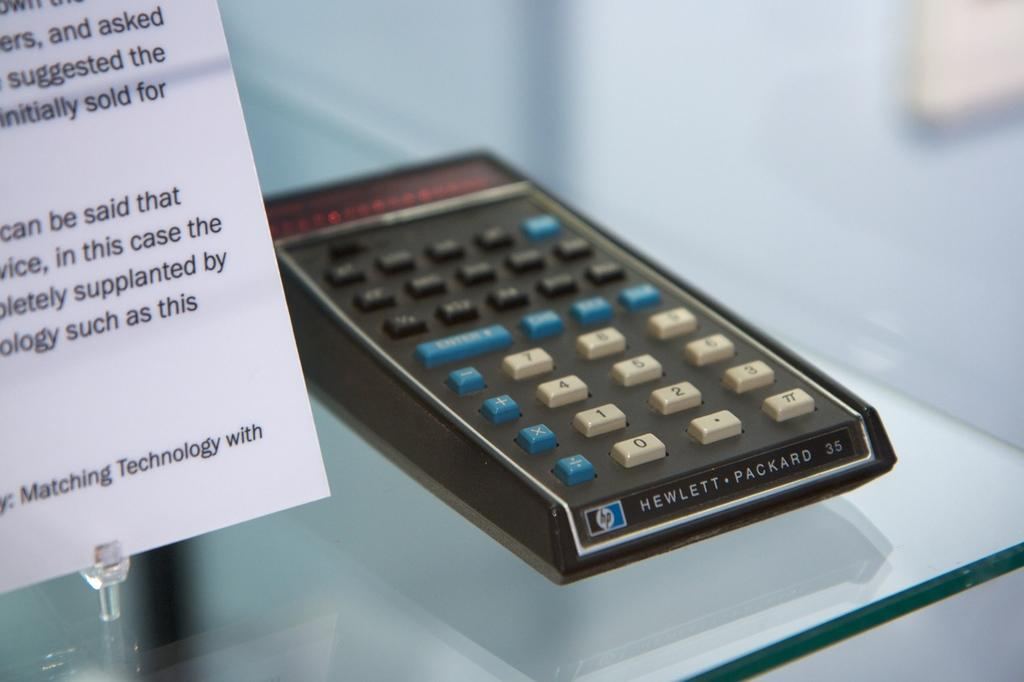<image>
Give a short and clear explanation of the subsequent image. a calculator item with Hewlett written on it 